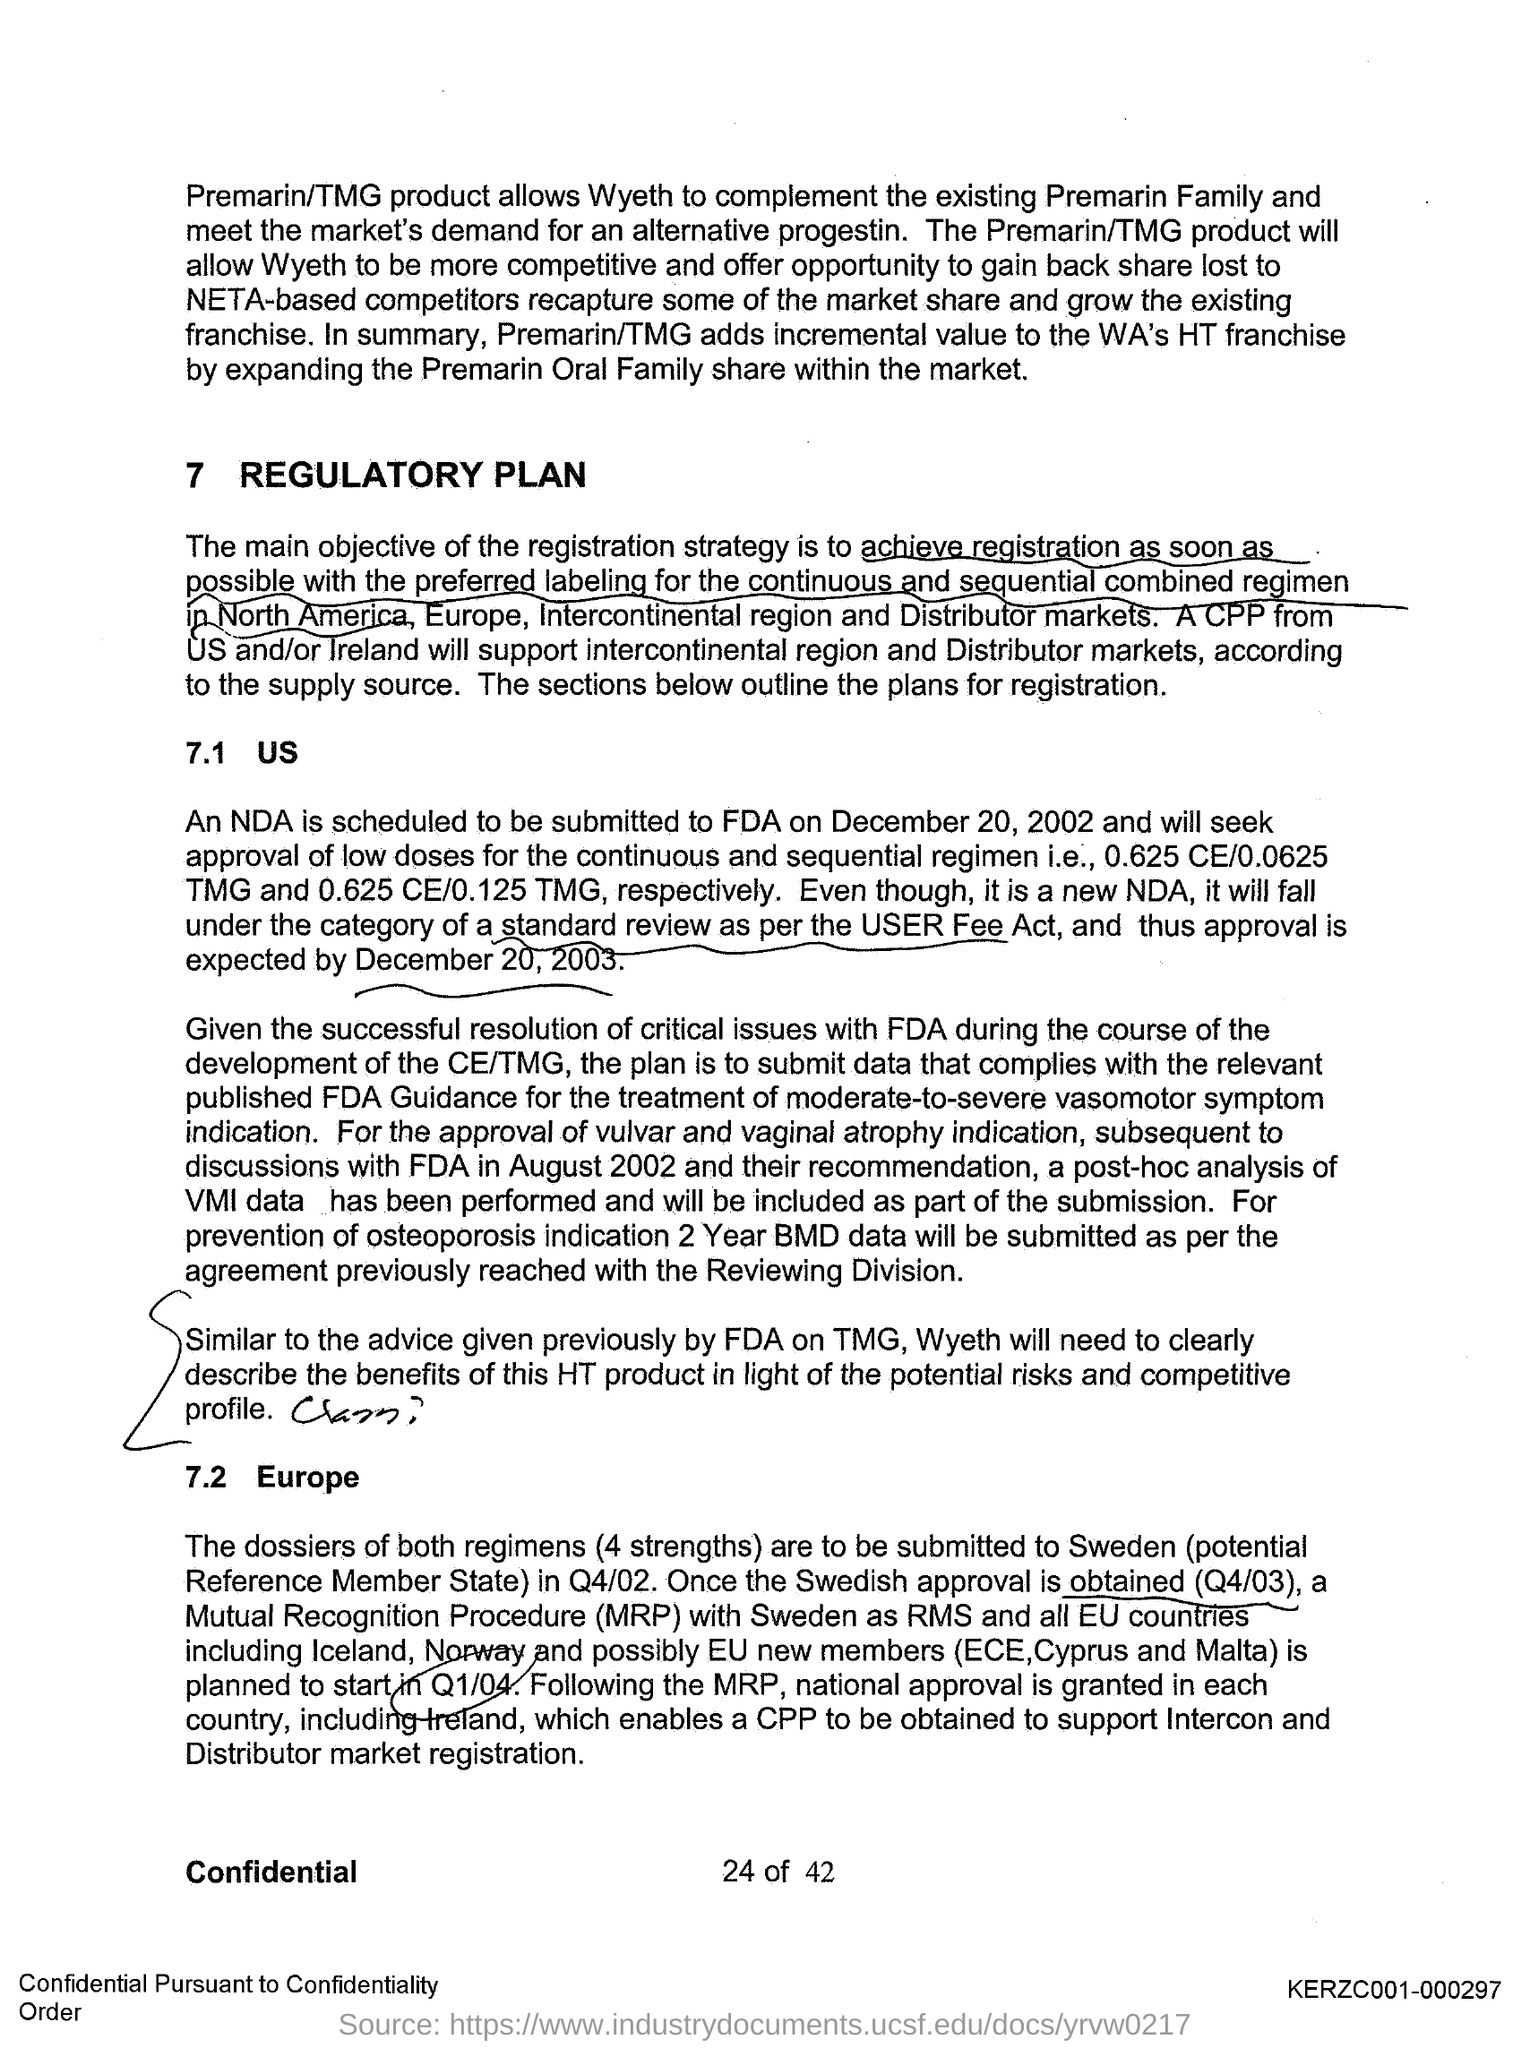Give some essential details in this illustration. The main objective of the registration strategy is to obtain registration as soon as possible with the preferred labeling for the continuous and sequential combined regimen in North America, Europe, the Intercontinental region, and distributor markets. A post-hoc analysis of VMI data has been performed and will be included as part of the submission for the approval of the vulvar and vaginal atrophy indication. The National Do Not Call Registry was scheduled to be submitted on December 20, 2002. The NDA submission to the FDA is scheduled for December 20, 2002. There will be a need for a CPP from the United States and/or Ireland to support the intercontinental region and Distributor markets. 